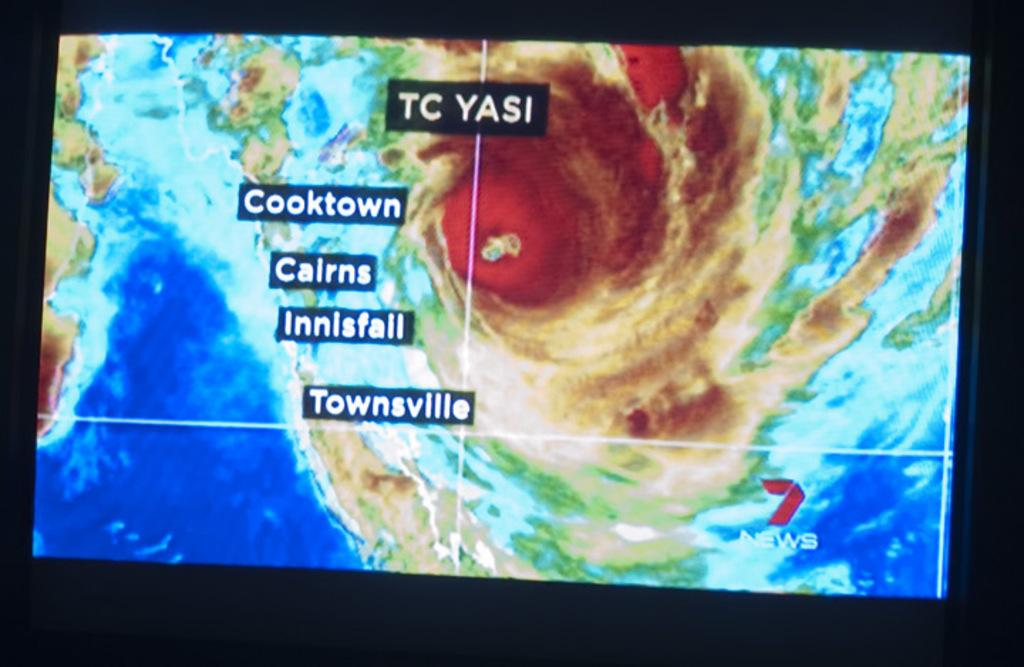<image>
Render a clear and concise summary of the photo. A screen showing tropical cyclone Yasi near Cooktown and Cairns. 